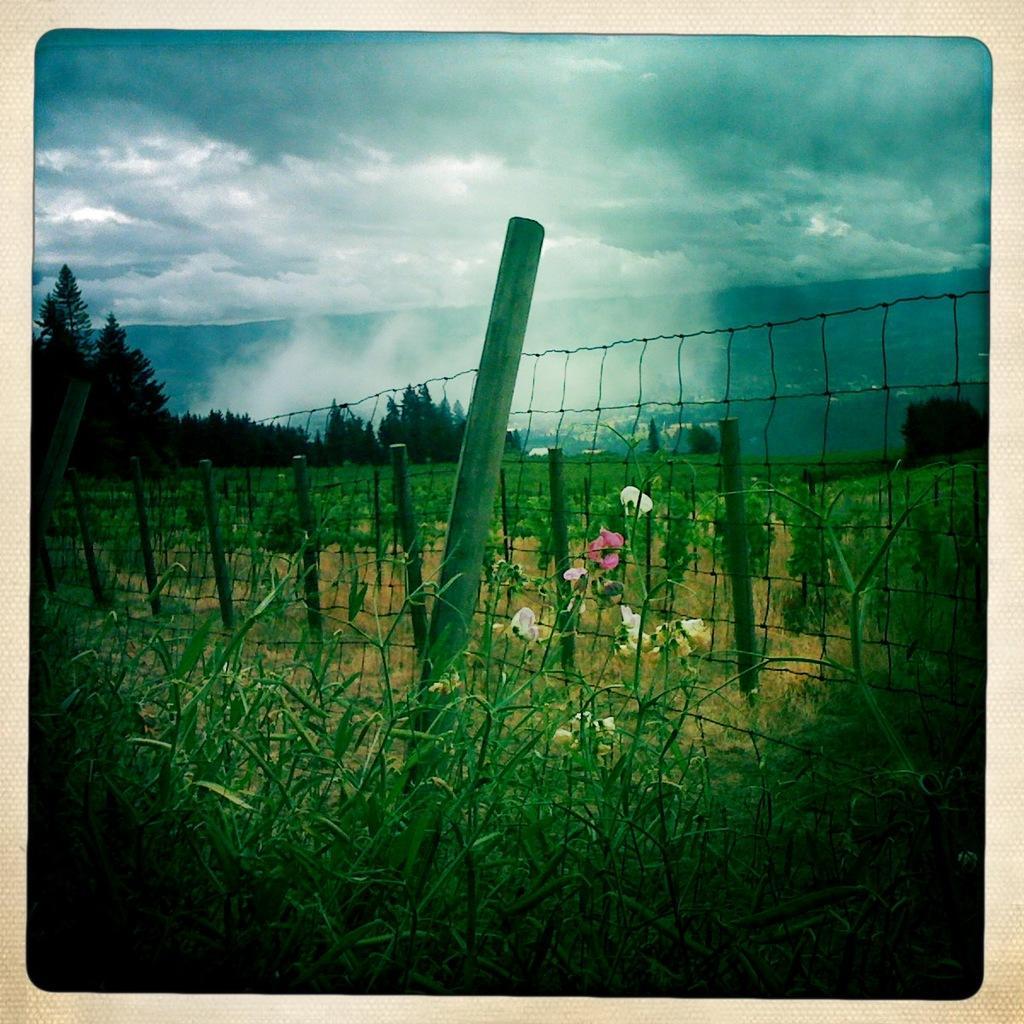In one or two sentences, can you explain what this image depicts? Here we can see plants, fence, poles, and flowers. In the background there are trees and sky with clouds. 